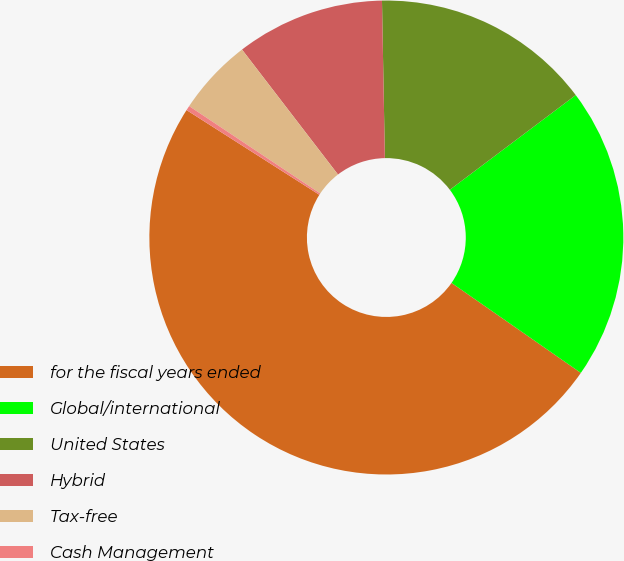Convert chart to OTSL. <chart><loc_0><loc_0><loc_500><loc_500><pie_chart><fcel>for the fiscal years ended<fcel>Global/international<fcel>United States<fcel>Hybrid<fcel>Tax-free<fcel>Cash Management<nl><fcel>49.36%<fcel>19.94%<fcel>15.03%<fcel>10.13%<fcel>5.22%<fcel>0.32%<nl></chart> 